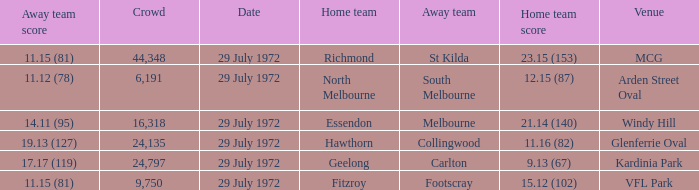Would you be able to parse every entry in this table? {'header': ['Away team score', 'Crowd', 'Date', 'Home team', 'Away team', 'Home team score', 'Venue'], 'rows': [['11.15 (81)', '44,348', '29 July 1972', 'Richmond', 'St Kilda', '23.15 (153)', 'MCG'], ['11.12 (78)', '6,191', '29 July 1972', 'North Melbourne', 'South Melbourne', '12.15 (87)', 'Arden Street Oval'], ['14.11 (95)', '16,318', '29 July 1972', 'Essendon', 'Melbourne', '21.14 (140)', 'Windy Hill'], ['19.13 (127)', '24,135', '29 July 1972', 'Hawthorn', 'Collingwood', '11.16 (82)', 'Glenferrie Oval'], ['17.17 (119)', '24,797', '29 July 1972', 'Geelong', 'Carlton', '9.13 (67)', 'Kardinia Park'], ['11.15 (81)', '9,750', '29 July 1972', 'Fitzroy', 'Footscray', '15.12 (102)', 'VFL Park']]} When did the away team footscray score 11.15 (81)? 29 July 1972. 